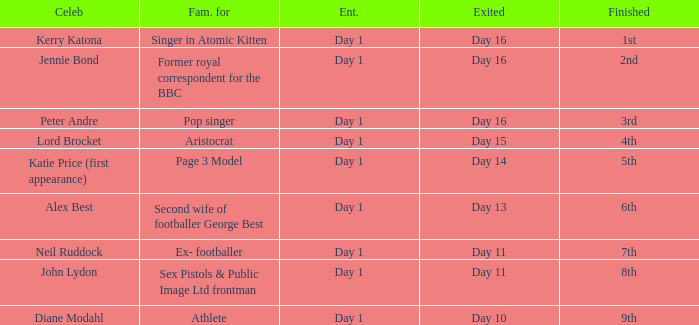Parse the full table. {'header': ['Celeb', 'Fam. for', 'Ent.', 'Exited', 'Finished'], 'rows': [['Kerry Katona', 'Singer in Atomic Kitten', 'Day 1', 'Day 16', '1st'], ['Jennie Bond', 'Former royal correspondent for the BBC', 'Day 1', 'Day 16', '2nd'], ['Peter Andre', 'Pop singer', 'Day 1', 'Day 16', '3rd'], ['Lord Brocket', 'Aristocrat', 'Day 1', 'Day 15', '4th'], ['Katie Price (first appearance)', 'Page 3 Model', 'Day 1', 'Day 14', '5th'], ['Alex Best', 'Second wife of footballer George Best', 'Day 1', 'Day 13', '6th'], ['Neil Ruddock', 'Ex- footballer', 'Day 1', 'Day 11', '7th'], ['John Lydon', 'Sex Pistols & Public Image Ltd frontman', 'Day 1', 'Day 11', '8th'], ['Diane Modahl', 'Athlete', 'Day 1', 'Day 10', '9th']]} Name who was famous for finished in 9th Athlete. 